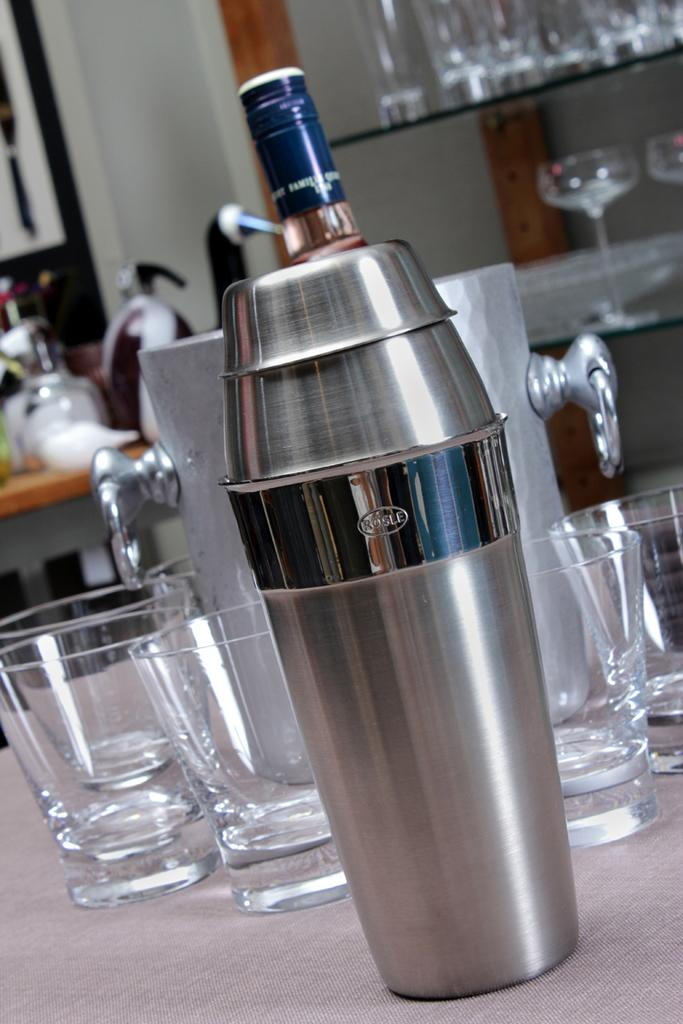<image>
Summarize the visual content of the image. A cocktail shaker with the word rusle on it stands in front of empty glasses. 